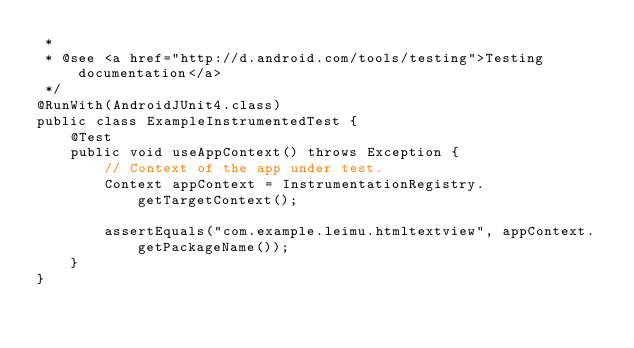Convert code to text. <code><loc_0><loc_0><loc_500><loc_500><_Java_> *
 * @see <a href="http://d.android.com/tools/testing">Testing documentation</a>
 */
@RunWith(AndroidJUnit4.class)
public class ExampleInstrumentedTest {
    @Test
    public void useAppContext() throws Exception {
        // Context of the app under test.
        Context appContext = InstrumentationRegistry.getTargetContext();

        assertEquals("com.example.leimu.htmltextview", appContext.getPackageName());
    }
}
</code> 